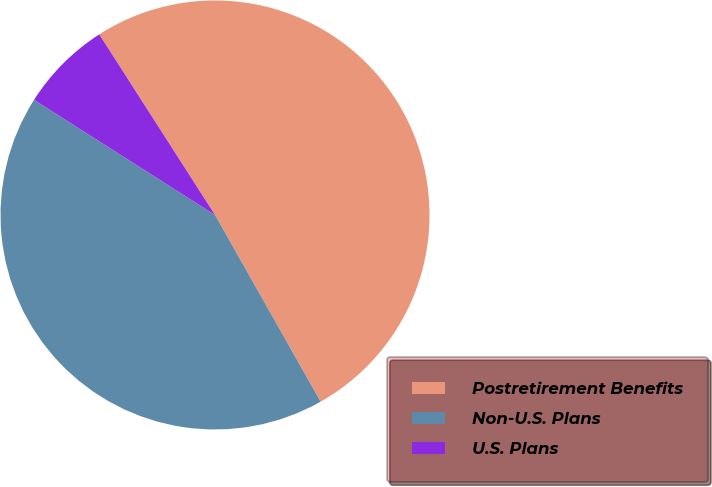Convert chart. <chart><loc_0><loc_0><loc_500><loc_500><pie_chart><fcel>Postretirement Benefits<fcel>Non-U.S. Plans<fcel>U.S. Plans<nl><fcel>50.88%<fcel>42.21%<fcel>6.91%<nl></chart> 